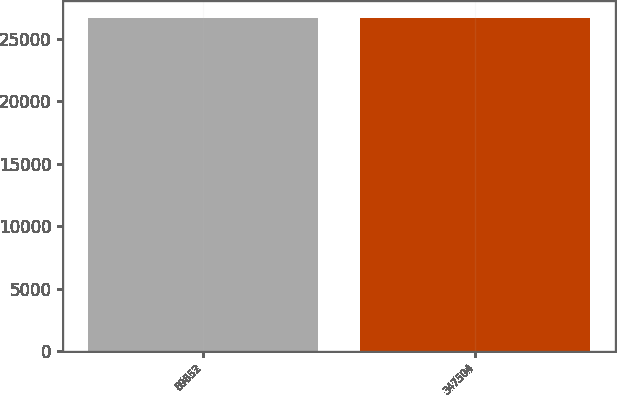Convert chart. <chart><loc_0><loc_0><loc_500><loc_500><bar_chart><fcel>89852<fcel>347504<nl><fcel>26701<fcel>26701.1<nl></chart> 